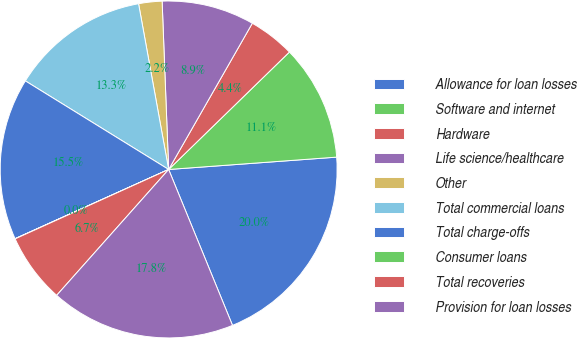<chart> <loc_0><loc_0><loc_500><loc_500><pie_chart><fcel>Allowance for loan losses<fcel>Software and internet<fcel>Hardware<fcel>Life science/healthcare<fcel>Other<fcel>Total commercial loans<fcel>Total charge-offs<fcel>Consumer loans<fcel>Total recoveries<fcel>Provision for loan losses<nl><fcel>19.98%<fcel>11.11%<fcel>4.45%<fcel>8.89%<fcel>2.24%<fcel>13.33%<fcel>15.55%<fcel>0.02%<fcel>6.67%<fcel>17.76%<nl></chart> 